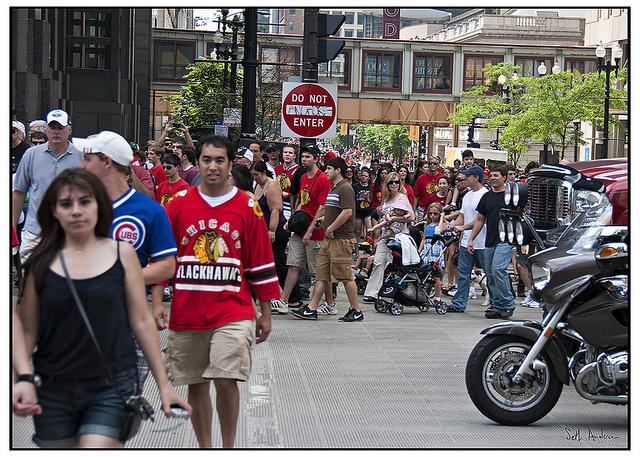Who captains the team of the jersey in red? blackhawks 